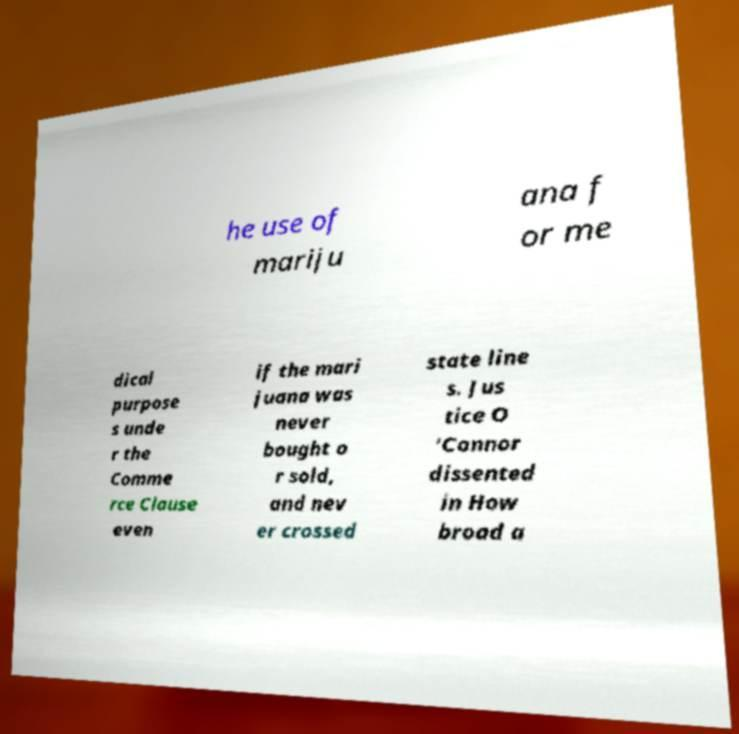Could you assist in decoding the text presented in this image and type it out clearly? he use of mariju ana f or me dical purpose s unde r the Comme rce Clause even if the mari juana was never bought o r sold, and nev er crossed state line s. Jus tice O 'Connor dissented in How broad a 